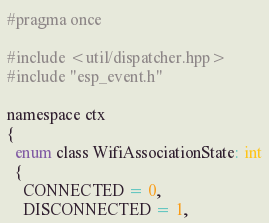<code> <loc_0><loc_0><loc_500><loc_500><_C_>#pragma once

#include <util/dispatcher.hpp>
#include "esp_event.h"

namespace ctx
{
  enum class WifiAssociationState: int
  {
    CONNECTED = 0,
    DISCONNECTED = 1,</code> 